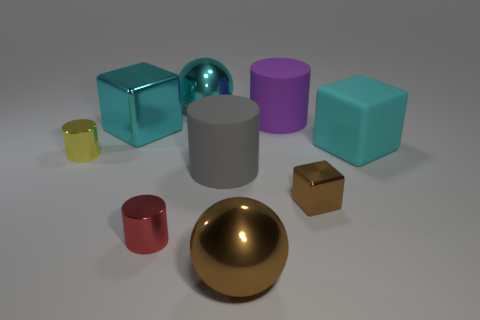Subtract all spheres. How many objects are left? 7 Add 3 big cyan things. How many big cyan things are left? 6 Add 2 large cyan things. How many large cyan things exist? 5 Subtract 1 brown cubes. How many objects are left? 8 Subtract all gray rubber things. Subtract all small metallic cubes. How many objects are left? 7 